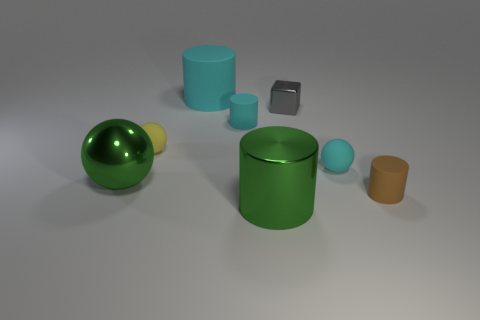Subtract 1 cylinders. How many cylinders are left? 3 Add 1 tiny green shiny cylinders. How many objects exist? 9 Subtract all balls. How many objects are left? 5 Add 2 green cylinders. How many green cylinders are left? 3 Add 4 big cyan metallic balls. How many big cyan metallic balls exist? 4 Subtract 1 brown cylinders. How many objects are left? 7 Subtract all large cyan metal spheres. Subtract all shiny cylinders. How many objects are left? 7 